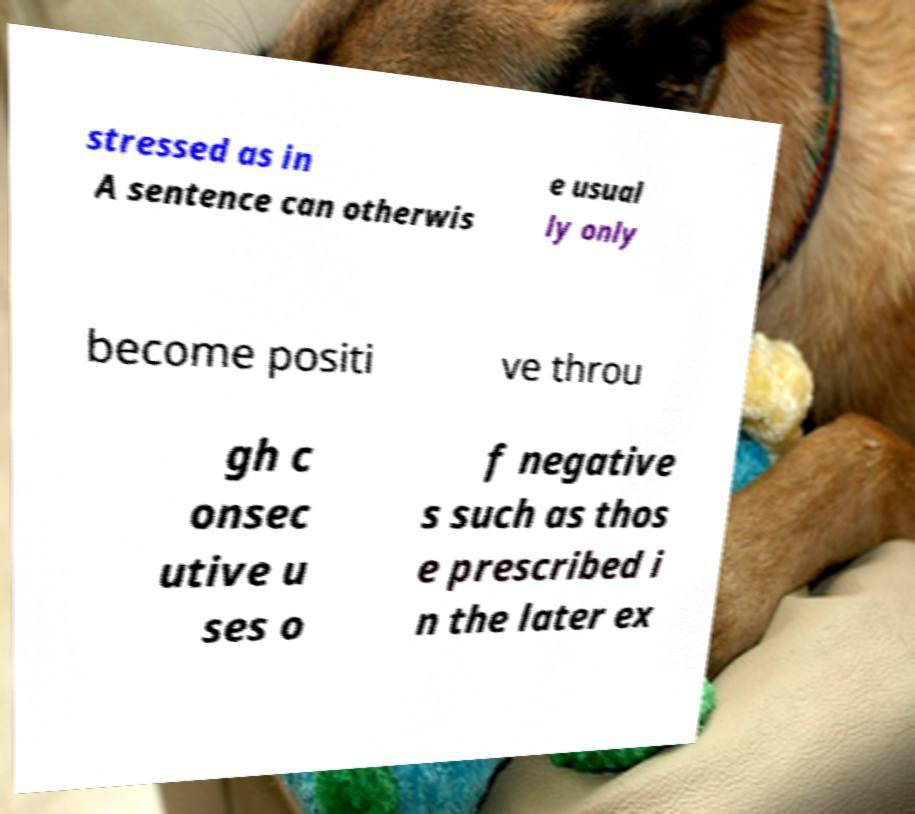I need the written content from this picture converted into text. Can you do that? stressed as in A sentence can otherwis e usual ly only become positi ve throu gh c onsec utive u ses o f negative s such as thos e prescribed i n the later ex 